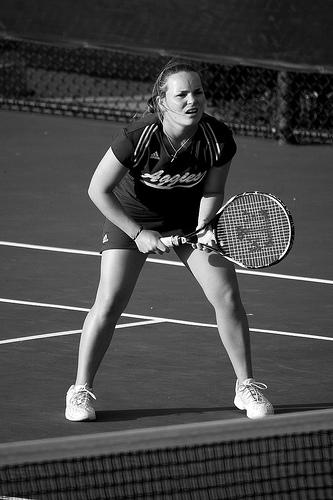Question: where is the racket?
Choices:
A. In her hands.
B. On the ground.
C. In the bag.
D. In the air.
Answer with the letter. Answer: A Question: what color is the court?
Choices:
A. Blue.
B. Gray.
C. Red.
D. Green.
Answer with the letter. Answer: B Question: when was this photo taken?
Choices:
A. During a tennis match.
B. At lunch.
C. During the business meeting.
D. During a soccer game.
Answer with the letter. Answer: A Question: who is wearing shorts?
Choices:
A. The tall man.
B. The girl.
C. The boy with a skateboard.
D. The tennis player.
Answer with the letter. Answer: B 